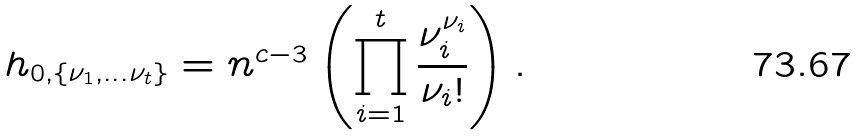Convert formula to latex. <formula><loc_0><loc_0><loc_500><loc_500>h _ { 0 , \{ \nu _ { 1 } , \dots \nu _ { t } \} } = n ^ { c - 3 } \left ( \prod _ { i = 1 } ^ { t } \frac { \nu _ { i } ^ { \nu _ { i } } } { \nu _ { i } ! } \right ) .</formula> 